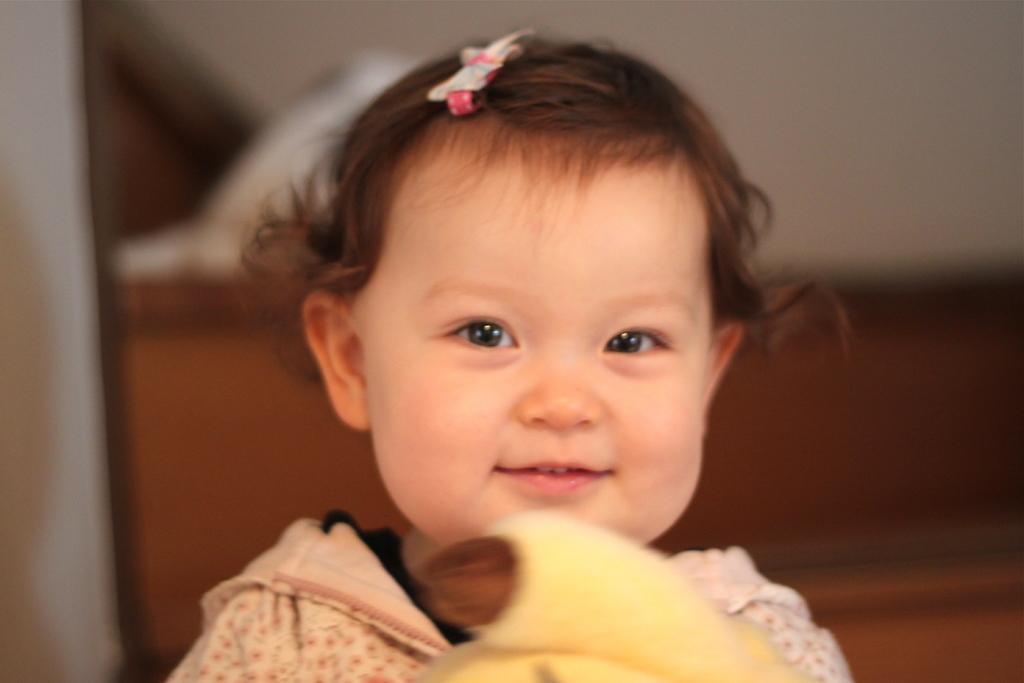In one or two sentences, can you explain what this image depicts? In the middle of the image a baby is smiling and holding a toy. Background of the image is blur. 